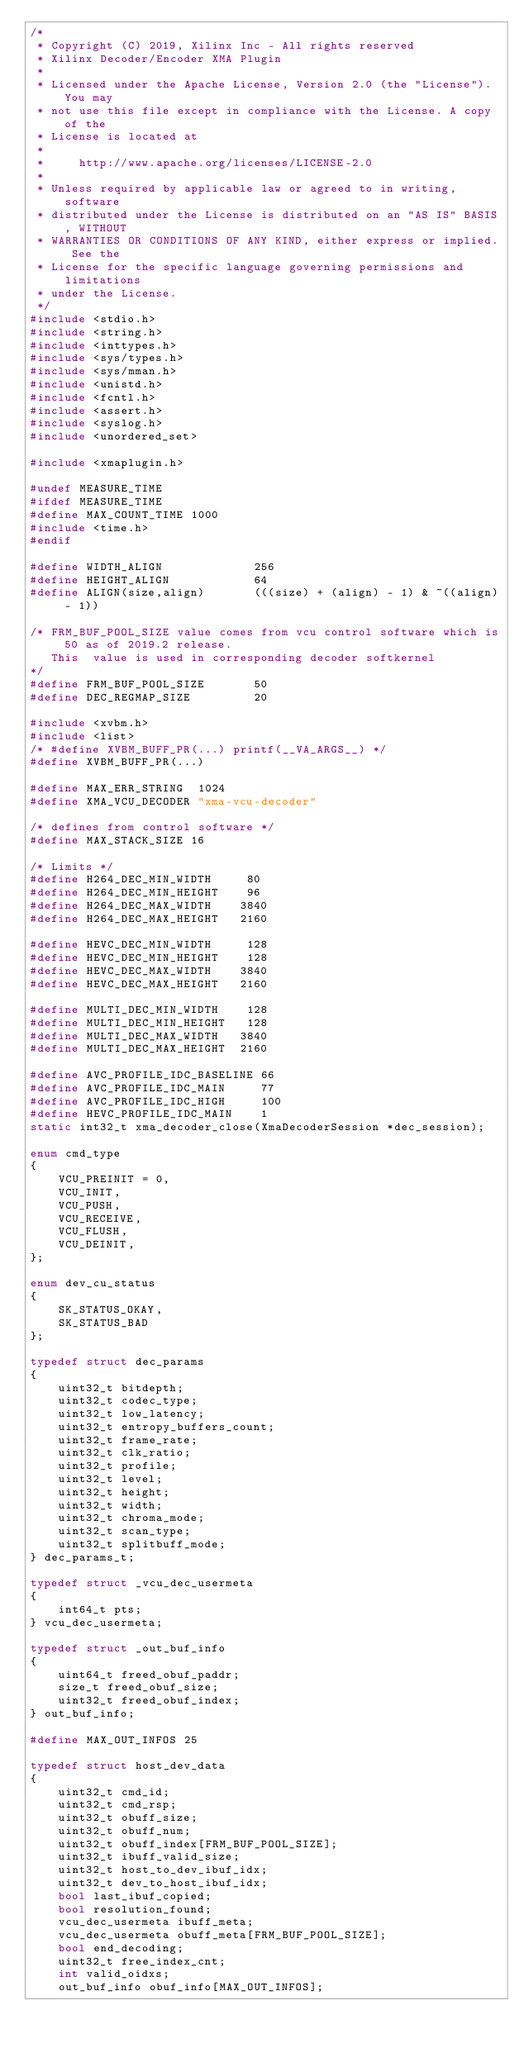<code> <loc_0><loc_0><loc_500><loc_500><_C++_>/*
 * Copyright (C) 2019, Xilinx Inc - All rights reserved
 * Xilinx Decoder/Encoder XMA Plugin
 *
 * Licensed under the Apache License, Version 2.0 (the "License"). You may
 * not use this file except in compliance with the License. A copy of the
 * License is located at
 *
 *     http://www.apache.org/licenses/LICENSE-2.0
 *
 * Unless required by applicable law or agreed to in writing, software
 * distributed under the License is distributed on an "AS IS" BASIS, WITHOUT
 * WARRANTIES OR CONDITIONS OF ANY KIND, either express or implied. See the
 * License for the specific language governing permissions and limitations
 * under the License.
 */
#include <stdio.h>
#include <string.h>
#include <inttypes.h>
#include <sys/types.h>
#include <sys/mman.h>
#include <unistd.h>
#include <fcntl.h>
#include <assert.h>
#include <syslog.h>
#include <unordered_set>

#include <xmaplugin.h>

#undef MEASURE_TIME
#ifdef MEASURE_TIME
#define MAX_COUNT_TIME 1000
#include <time.h>
#endif

#define WIDTH_ALIGN             256
#define HEIGHT_ALIGN            64
#define ALIGN(size,align)       (((size) + (align) - 1) & ~((align) - 1))

/* FRM_BUF_POOL_SIZE value comes from vcu control software which is 50 as of 2019.2 release.
   This  value is used in corresponding decoder softkernel
*/
#define FRM_BUF_POOL_SIZE       50
#define DEC_REGMAP_SIZE         20

#include <xvbm.h>
#include <list>
/* #define XVBM_BUFF_PR(...) printf(__VA_ARGS__) */
#define XVBM_BUFF_PR(...)

#define MAX_ERR_STRING  1024
#define XMA_VCU_DECODER "xma-vcu-decoder"

/* defines from control software */
#define MAX_STACK_SIZE 16

/* Limits */
#define H264_DEC_MIN_WIDTH     80
#define H264_DEC_MIN_HEIGHT    96
#define H264_DEC_MAX_WIDTH    3840
#define H264_DEC_MAX_HEIGHT   2160

#define HEVC_DEC_MIN_WIDTH     128
#define HEVC_DEC_MIN_HEIGHT    128
#define HEVC_DEC_MAX_WIDTH    3840
#define HEVC_DEC_MAX_HEIGHT   2160

#define MULTI_DEC_MIN_WIDTH    128
#define MULTI_DEC_MIN_HEIGHT   128
#define MULTI_DEC_MAX_WIDTH   3840
#define MULTI_DEC_MAX_HEIGHT  2160

#define AVC_PROFILE_IDC_BASELINE 66
#define AVC_PROFILE_IDC_MAIN     77
#define AVC_PROFILE_IDC_HIGH     100
#define HEVC_PROFILE_IDC_MAIN    1
static int32_t xma_decoder_close(XmaDecoderSession *dec_session);

enum cmd_type
{
    VCU_PREINIT = 0,
    VCU_INIT,
    VCU_PUSH,
    VCU_RECEIVE,
    VCU_FLUSH,
    VCU_DEINIT,
};

enum dev_cu_status
{
    SK_STATUS_OKAY,
    SK_STATUS_BAD
};

typedef struct dec_params
{
    uint32_t bitdepth;
    uint32_t codec_type;
    uint32_t low_latency;
    uint32_t entropy_buffers_count;
    uint32_t frame_rate;
    uint32_t clk_ratio;
    uint32_t profile;
    uint32_t level;
    uint32_t height;
    uint32_t width;
    uint32_t chroma_mode;
    uint32_t scan_type;
    uint32_t splitbuff_mode;
} dec_params_t;

typedef struct _vcu_dec_usermeta
{
    int64_t pts;
} vcu_dec_usermeta;

typedef struct _out_buf_info
{
    uint64_t freed_obuf_paddr;
    size_t freed_obuf_size;
    uint32_t freed_obuf_index;
} out_buf_info;

#define MAX_OUT_INFOS 25

typedef struct host_dev_data
{
    uint32_t cmd_id;
    uint32_t cmd_rsp;
    uint32_t obuff_size;
    uint32_t obuff_num;
    uint32_t obuff_index[FRM_BUF_POOL_SIZE];
    uint32_t ibuff_valid_size;
    uint32_t host_to_dev_ibuf_idx;
    uint32_t dev_to_host_ibuf_idx;
    bool last_ibuf_copied;
    bool resolution_found;
    vcu_dec_usermeta ibuff_meta;
    vcu_dec_usermeta obuff_meta[FRM_BUF_POOL_SIZE];
    bool end_decoding;
    uint32_t free_index_cnt;
    int valid_oidxs;
    out_buf_info obuf_info[MAX_OUT_INFOS];</code> 